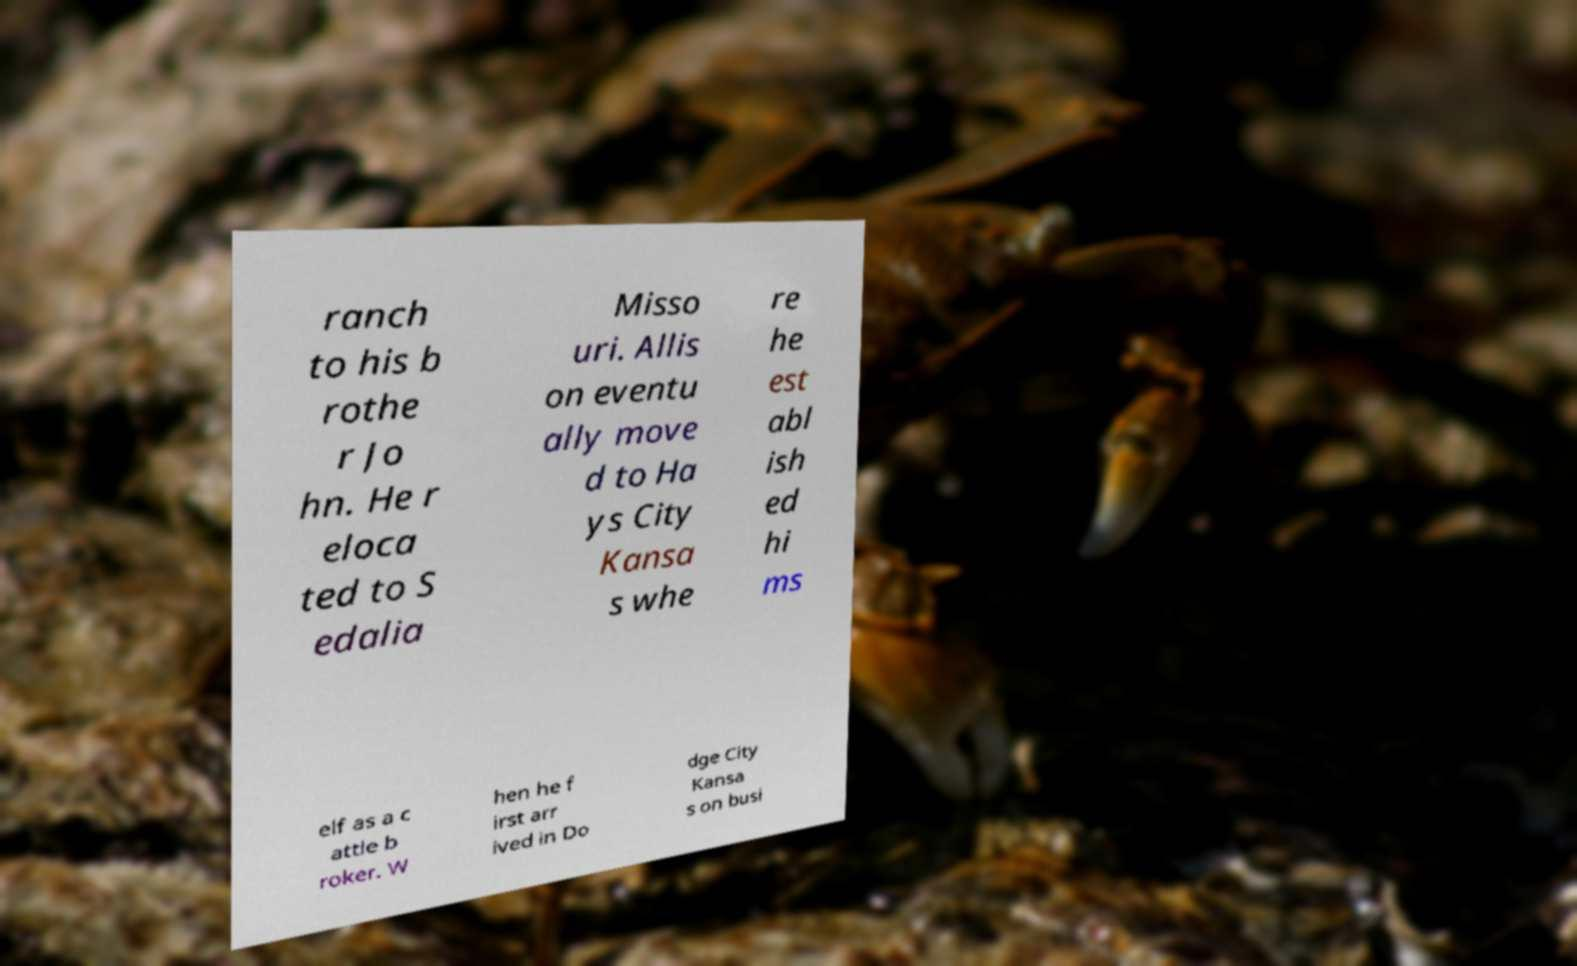What messages or text are displayed in this image? I need them in a readable, typed format. ranch to his b rothe r Jo hn. He r eloca ted to S edalia Misso uri. Allis on eventu ally move d to Ha ys City Kansa s whe re he est abl ish ed hi ms elf as a c attle b roker. W hen he f irst arr ived in Do dge City Kansa s on busi 